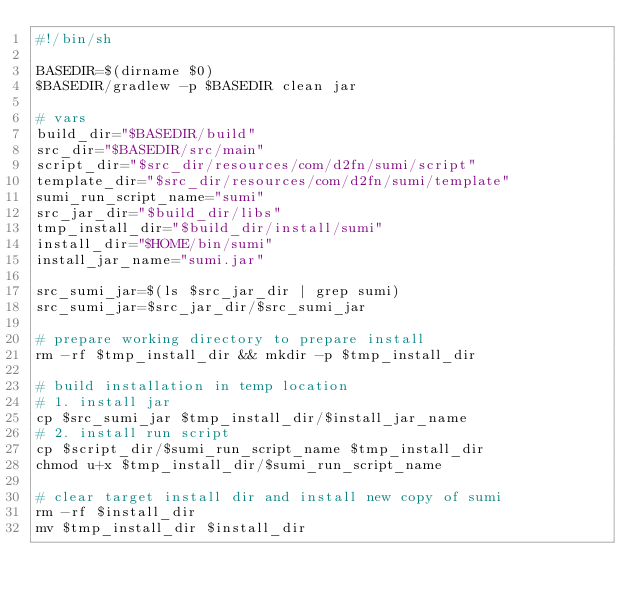Convert code to text. <code><loc_0><loc_0><loc_500><loc_500><_Bash_>#!/bin/sh

BASEDIR=$(dirname $0)
$BASEDIR/gradlew -p $BASEDIR clean jar

# vars
build_dir="$BASEDIR/build"
src_dir="$BASEDIR/src/main"
script_dir="$src_dir/resources/com/d2fn/sumi/script"
template_dir="$src_dir/resources/com/d2fn/sumi/template"
sumi_run_script_name="sumi"
src_jar_dir="$build_dir/libs"
tmp_install_dir="$build_dir/install/sumi"
install_dir="$HOME/bin/sumi"
install_jar_name="sumi.jar"

src_sumi_jar=$(ls $src_jar_dir | grep sumi)
src_sumi_jar=$src_jar_dir/$src_sumi_jar

# prepare working directory to prepare install
rm -rf $tmp_install_dir && mkdir -p $tmp_install_dir

# build installation in temp location
# 1. install jar
cp $src_sumi_jar $tmp_install_dir/$install_jar_name
# 2. install run script
cp $script_dir/$sumi_run_script_name $tmp_install_dir
chmod u+x $tmp_install_dir/$sumi_run_script_name

# clear target install dir and install new copy of sumi
rm -rf $install_dir
mv $tmp_install_dir $install_dir
</code> 